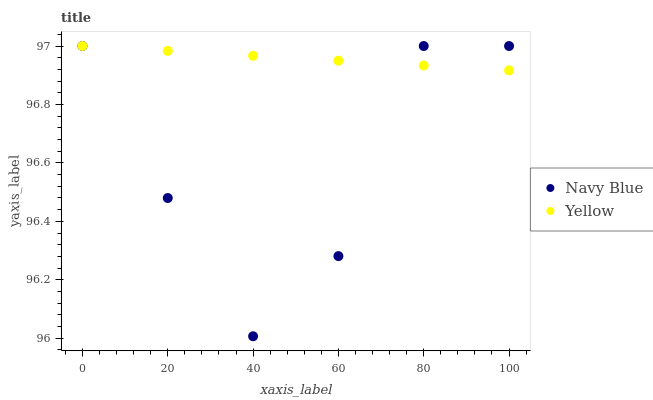Does Navy Blue have the minimum area under the curve?
Answer yes or no. Yes. Does Yellow have the maximum area under the curve?
Answer yes or no. Yes. Does Yellow have the minimum area under the curve?
Answer yes or no. No. Is Yellow the smoothest?
Answer yes or no. Yes. Is Navy Blue the roughest?
Answer yes or no. Yes. Is Yellow the roughest?
Answer yes or no. No. Does Navy Blue have the lowest value?
Answer yes or no. Yes. Does Yellow have the lowest value?
Answer yes or no. No. Does Yellow have the highest value?
Answer yes or no. Yes. Does Yellow intersect Navy Blue?
Answer yes or no. Yes. Is Yellow less than Navy Blue?
Answer yes or no. No. Is Yellow greater than Navy Blue?
Answer yes or no. No. 